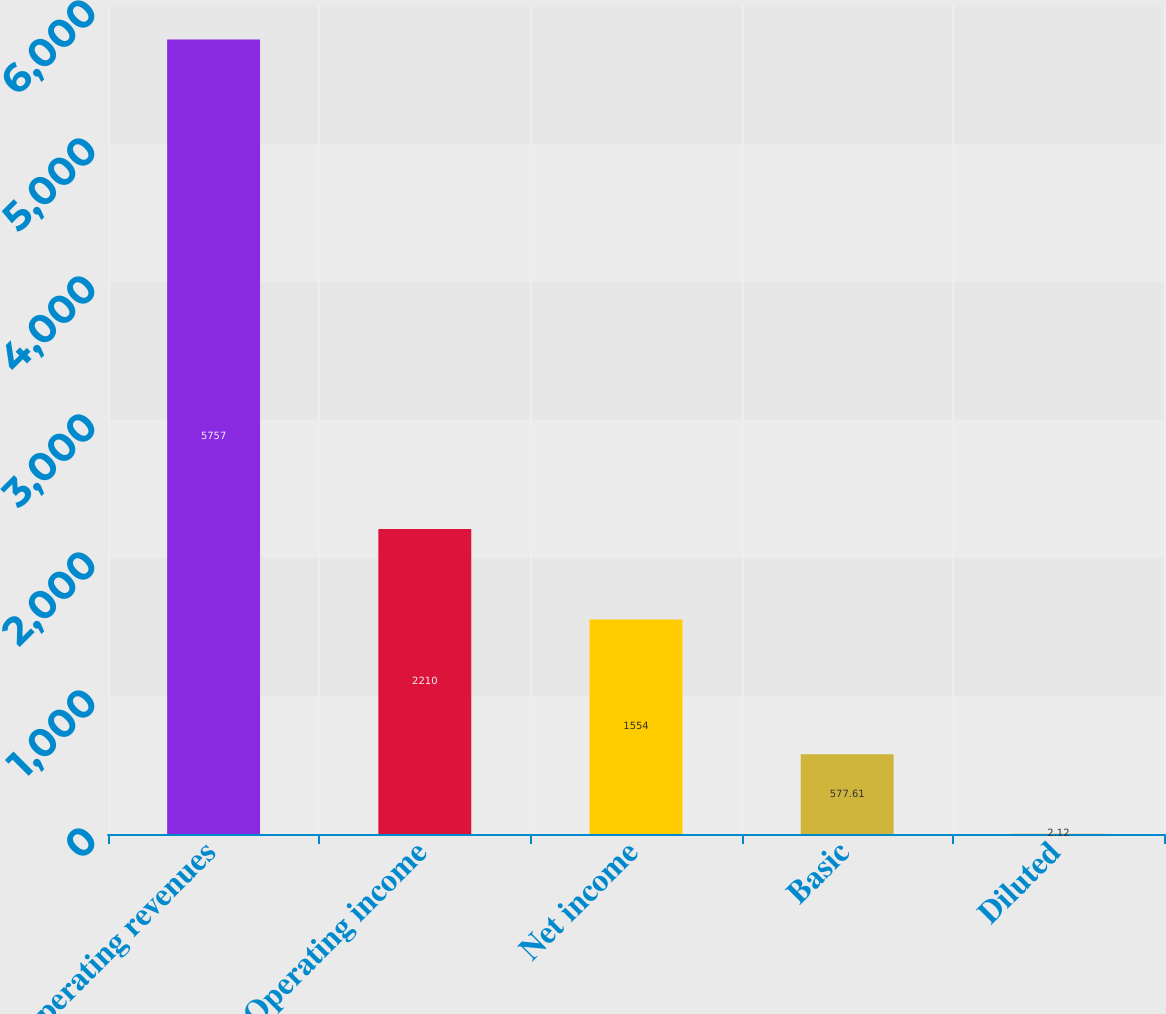Convert chart to OTSL. <chart><loc_0><loc_0><loc_500><loc_500><bar_chart><fcel>Operating revenues<fcel>Operating income<fcel>Net income<fcel>Basic<fcel>Diluted<nl><fcel>5757<fcel>2210<fcel>1554<fcel>577.61<fcel>2.12<nl></chart> 